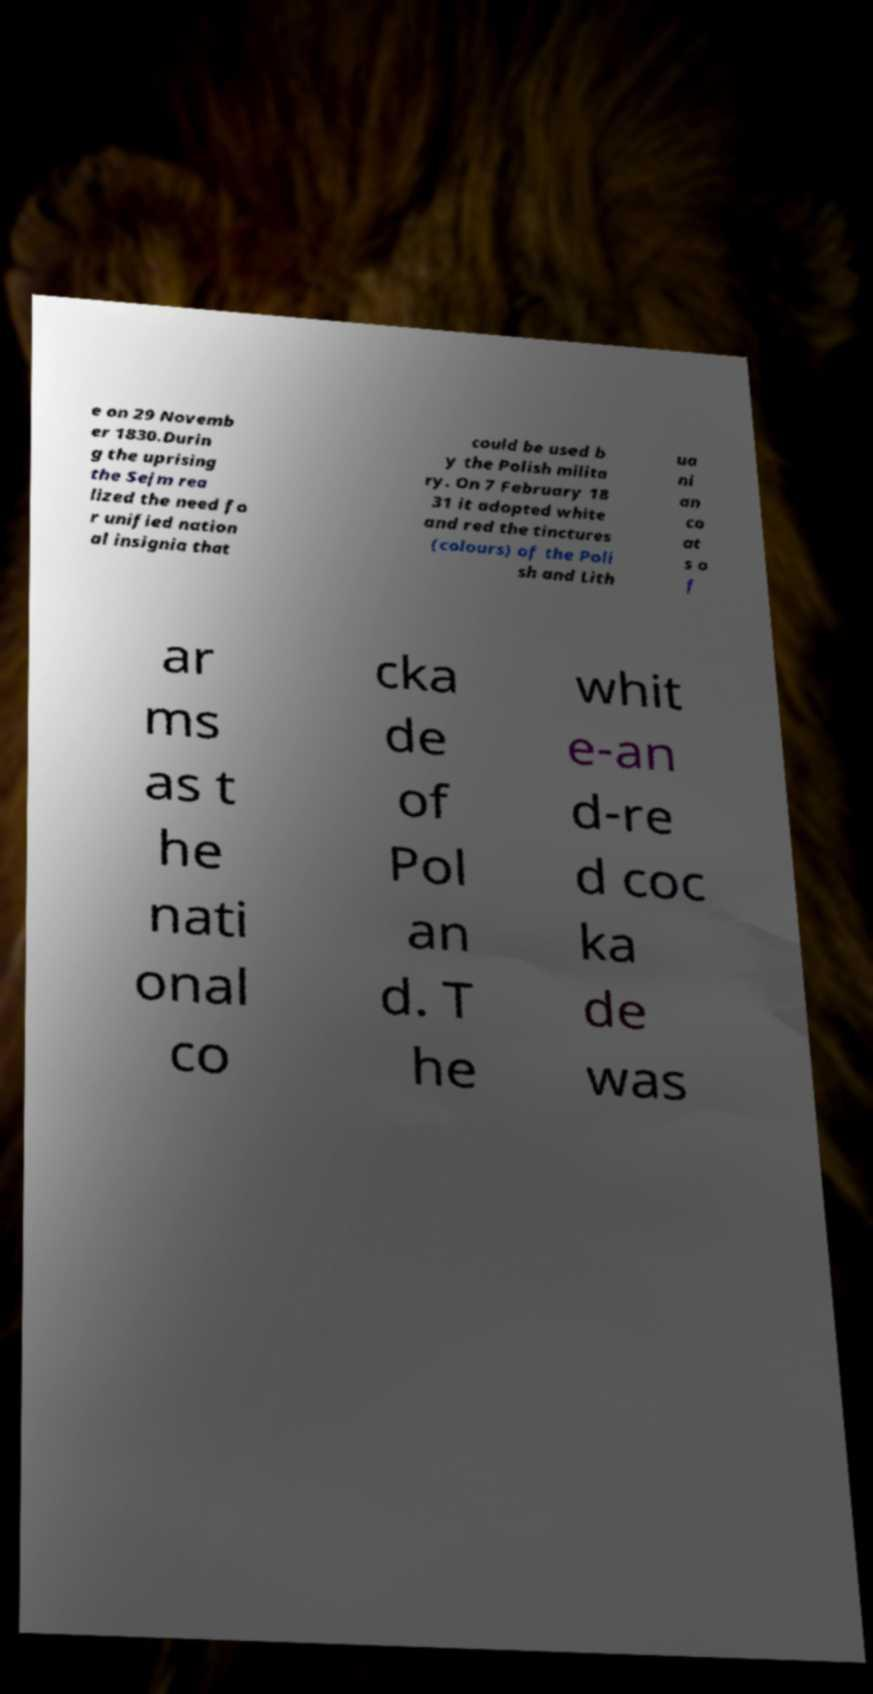Could you assist in decoding the text presented in this image and type it out clearly? e on 29 Novemb er 1830.Durin g the uprising the Sejm rea lized the need fo r unified nation al insignia that could be used b y the Polish milita ry. On 7 February 18 31 it adopted white and red the tinctures (colours) of the Poli sh and Lith ua ni an co at s o f ar ms as t he nati onal co cka de of Pol an d. T he whit e-an d-re d coc ka de was 